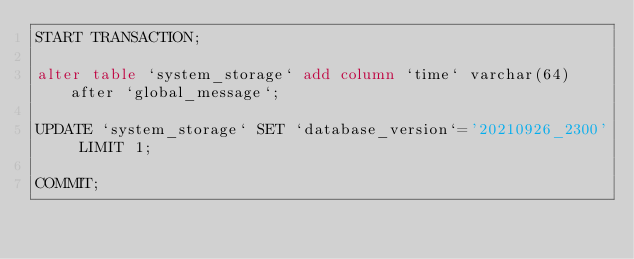Convert code to text. <code><loc_0><loc_0><loc_500><loc_500><_SQL_>START TRANSACTION;

alter table `system_storage` add column `time` varchar(64) after `global_message`;

UPDATE `system_storage` SET `database_version`='20210926_2300' LIMIT 1;

COMMIT;</code> 